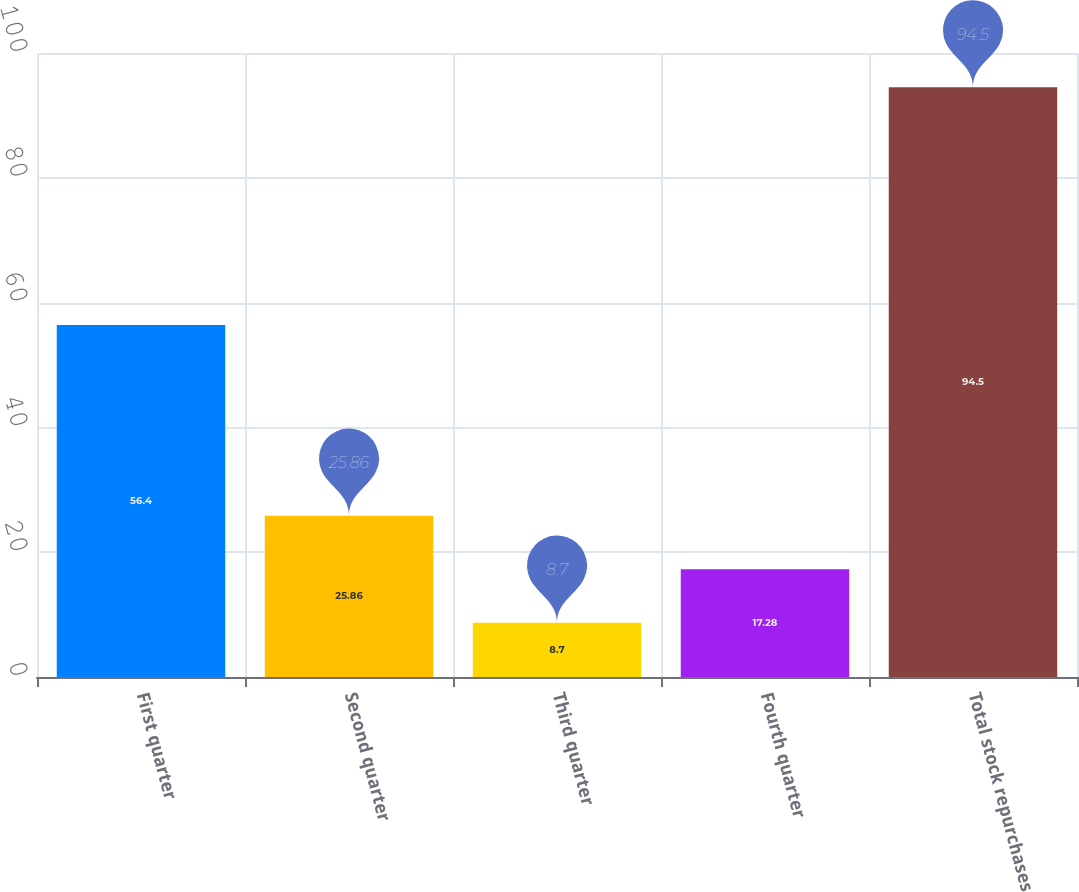<chart> <loc_0><loc_0><loc_500><loc_500><bar_chart><fcel>First quarter<fcel>Second quarter<fcel>Third quarter<fcel>Fourth quarter<fcel>Total stock repurchases<nl><fcel>56.4<fcel>25.86<fcel>8.7<fcel>17.28<fcel>94.5<nl></chart> 